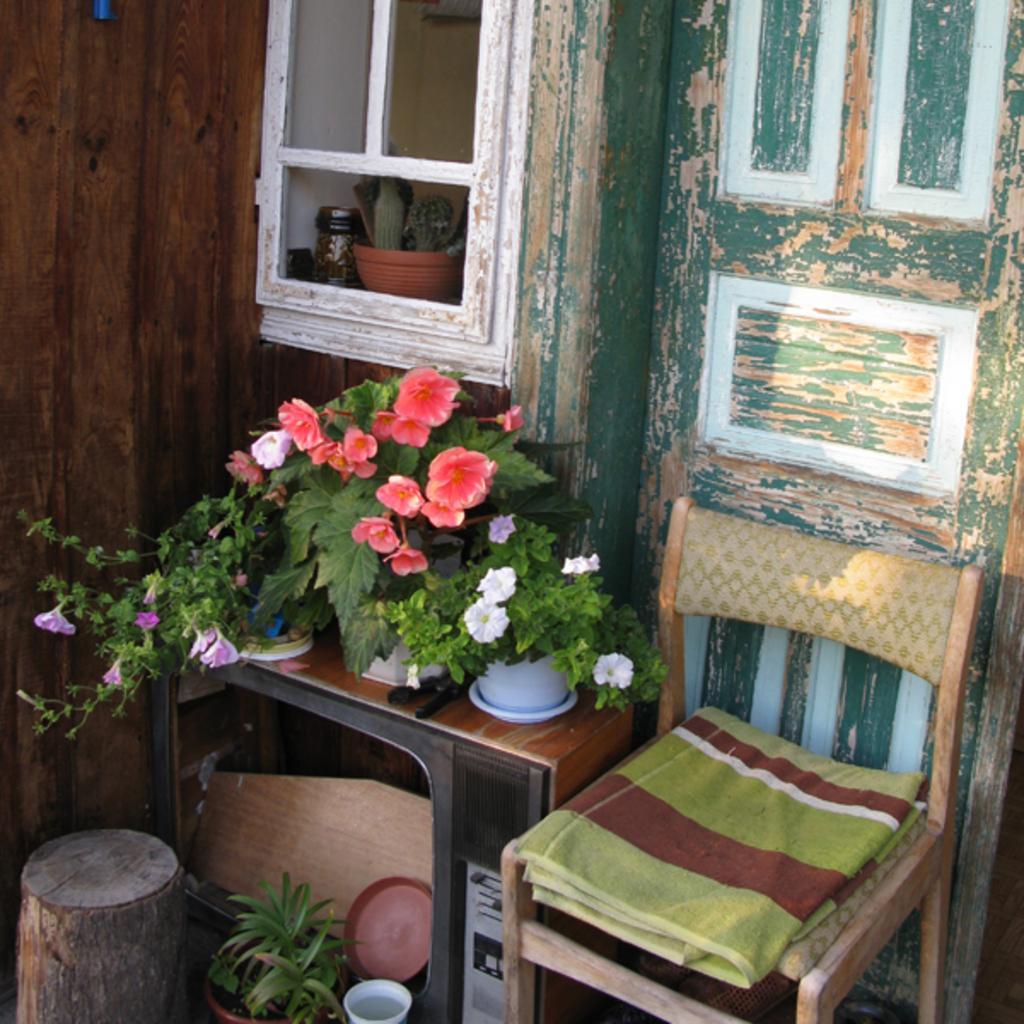How would you summarize this image in a sentence or two? In the image we can see there are small plants on which there are flowers and there is a chair on which there is a towel kept and the door at the behind is in green colour and beside it on the window there is a pot in which cactus plant is grown. 